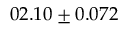<formula> <loc_0><loc_0><loc_500><loc_500>0 2 . 1 0 \pm 0 . 0 7 2</formula> 